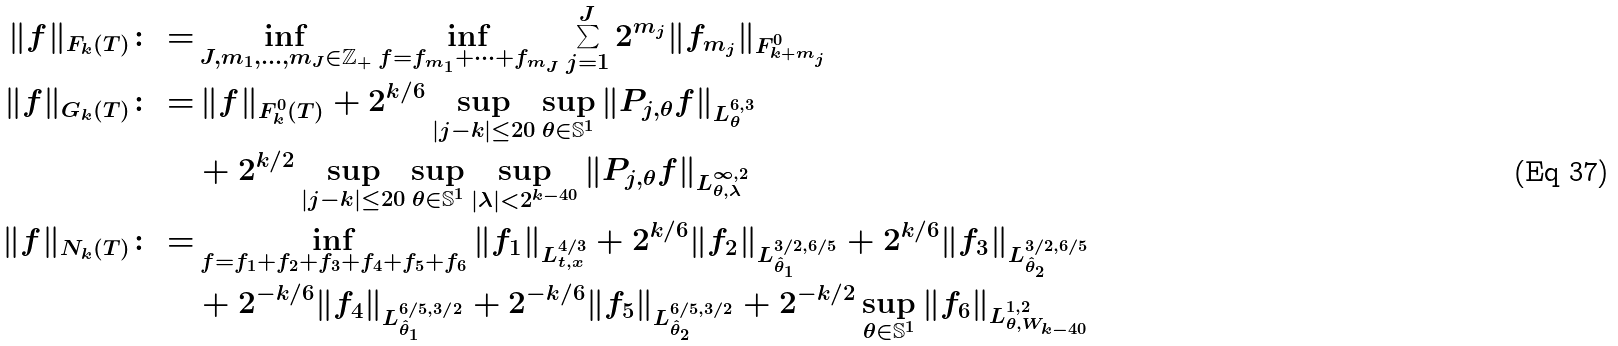<formula> <loc_0><loc_0><loc_500><loc_500>\| f \| _ { F _ { k } ( T ) } \colon = & \inf _ { J , m _ { 1 } , \dots , m _ { J } \in \mathbb { Z } _ { + } } \inf _ { f = f _ { m _ { 1 } } + \cdots + f _ { m _ { J } } } \sum _ { j = 1 } ^ { J } 2 ^ { m _ { j } } \| f _ { m _ { j } } \| _ { F _ { k + m _ { j } } ^ { 0 } } \\ \| f \| _ { G _ { k } ( T ) } \colon = & \, \| f \| _ { F _ { k } ^ { 0 } ( T ) } + 2 ^ { k / 6 } \sup _ { | j - k | \leq 2 0 } \sup _ { \theta \in \mathbb { S } ^ { 1 } } \| P _ { j , \theta } f \| _ { L _ { \theta } ^ { 6 , 3 } } \\ & + 2 ^ { k / 2 } \sup _ { | j - k | \leq 2 0 } \sup _ { \theta \in \mathbb { S } ^ { 1 } } \sup _ { | \lambda | < 2 ^ { k - 4 0 } } \| P _ { j , \theta } f \| _ { L _ { \theta , \lambda } ^ { \infty , 2 } } \\ \| f \| _ { N _ { k } ( T ) } \colon = & \inf _ { f = f _ { 1 } + f _ { 2 } + f _ { 3 } + f _ { 4 } + f _ { 5 } + f _ { 6 } } \| f _ { 1 } \| _ { L _ { t , x } ^ { 4 / 3 } } + 2 ^ { k / 6 } \| f _ { 2 } \| _ { L _ { \hat { \theta } _ { 1 } } ^ { 3 / 2 , 6 / 5 } } + 2 ^ { k / 6 } \| f _ { 3 } \| _ { L _ { \hat { \theta } _ { 2 } } ^ { 3 / 2 , 6 / 5 } } \\ & + 2 ^ { - k / 6 } \| f _ { 4 } \| _ { L ^ { 6 / 5 , 3 / 2 } _ { \hat { \theta } _ { 1 } } } + 2 ^ { - k / 6 } \| f _ { 5 } \| _ { L ^ { 6 / 5 , 3 / 2 } _ { \hat { \theta } _ { 2 } } } + 2 ^ { - k / 2 } \sup _ { \theta \in \mathbb { S } ^ { 1 } } \| f _ { 6 } \| _ { L _ { \theta , W _ { k - 4 0 } } ^ { 1 , 2 } }</formula> 